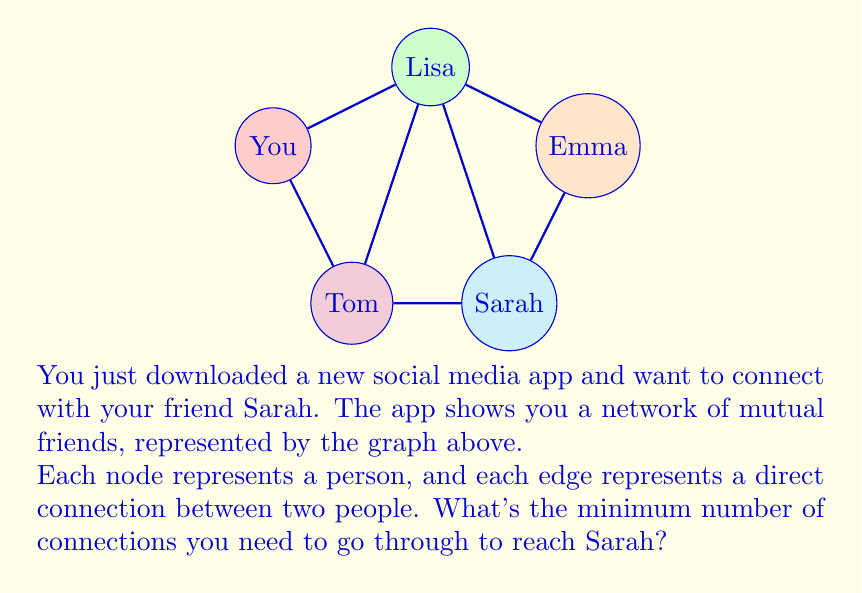Give your solution to this math problem. To find the shortest path between you and Sarah in this social network graph, we can use a simple breadth-first search (BFS) algorithm. Let's go through the process step-by-step:

1. Start at your node (the source node).
2. Explore all directly connected nodes:
   - You are directly connected to Lisa and Tom.
3. Since Sarah is not among these direct connections, we move to the next level:
   - From Lisa, we can reach Emma and Sarah.
   - From Tom, we can reach Sarah.
4. We've found Sarah at this level, so we stop here.

The shortest path can be either:
1. You → Lisa → Sarah
2. You → Tom → Sarah

Both of these paths have a length of 2, meaning you need to go through 2 connections to reach Sarah.

In graph theory terms, we're finding the shortest path in an unweighted graph, where the length of the path is simply the number of edges traversed. The distance between you and Sarah is 2, which is the minimum number of edges in any path connecting your node to Sarah's node.
Answer: 2 connections 